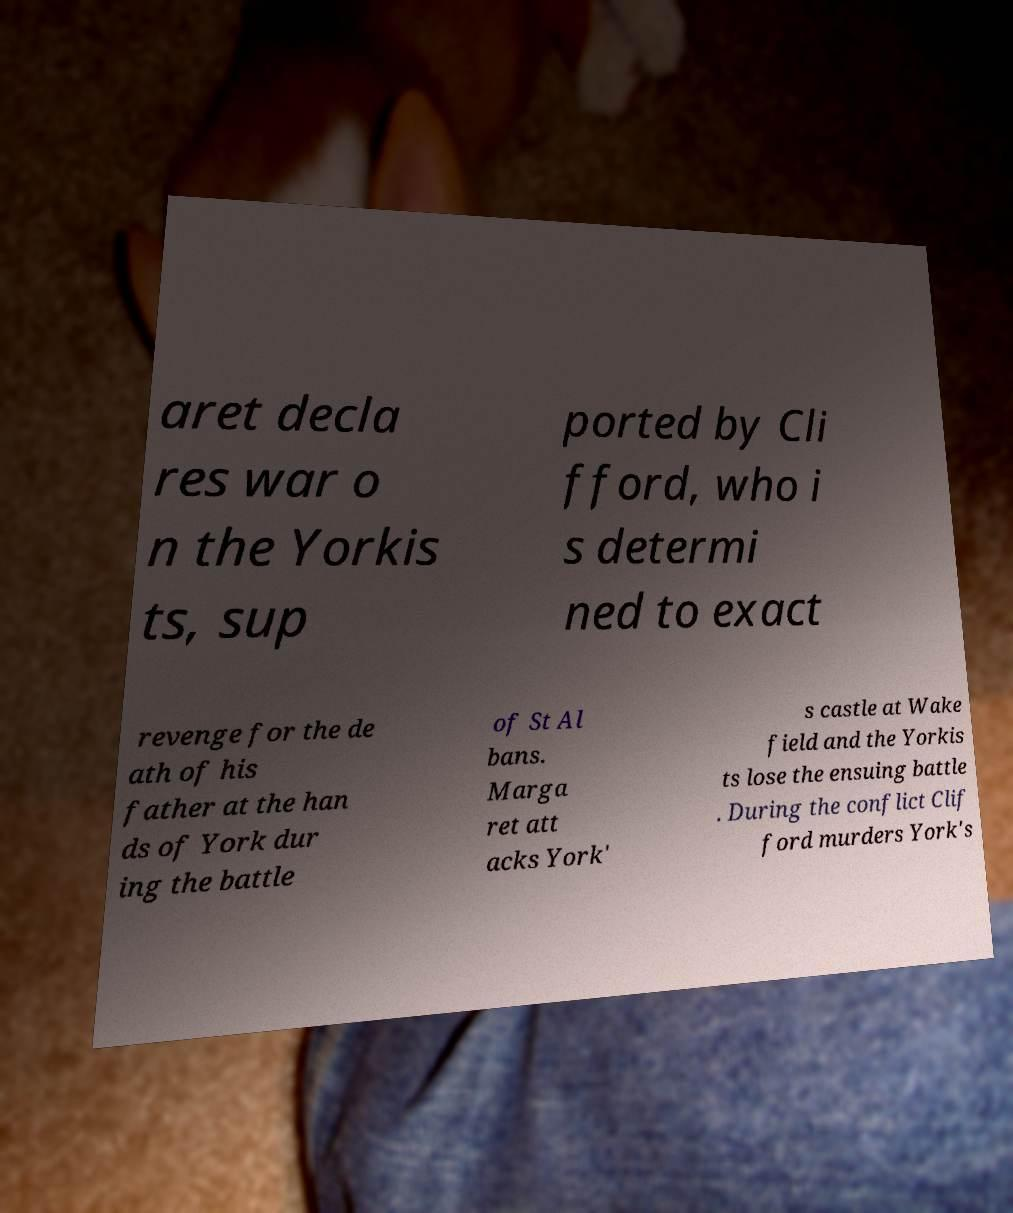Can you accurately transcribe the text from the provided image for me? aret decla res war o n the Yorkis ts, sup ported by Cli fford, who i s determi ned to exact revenge for the de ath of his father at the han ds of York dur ing the battle of St Al bans. Marga ret att acks York' s castle at Wake field and the Yorkis ts lose the ensuing battle . During the conflict Clif ford murders York's 